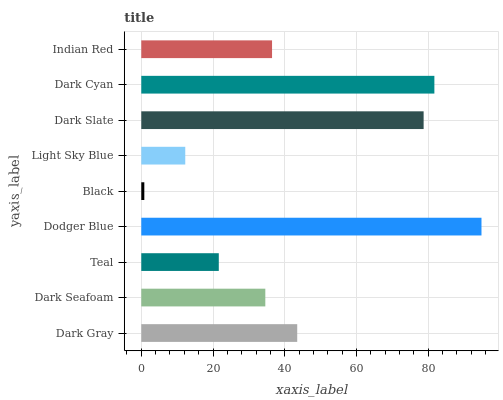Is Black the minimum?
Answer yes or no. Yes. Is Dodger Blue the maximum?
Answer yes or no. Yes. Is Dark Seafoam the minimum?
Answer yes or no. No. Is Dark Seafoam the maximum?
Answer yes or no. No. Is Dark Gray greater than Dark Seafoam?
Answer yes or no. Yes. Is Dark Seafoam less than Dark Gray?
Answer yes or no. Yes. Is Dark Seafoam greater than Dark Gray?
Answer yes or no. No. Is Dark Gray less than Dark Seafoam?
Answer yes or no. No. Is Indian Red the high median?
Answer yes or no. Yes. Is Indian Red the low median?
Answer yes or no. Yes. Is Light Sky Blue the high median?
Answer yes or no. No. Is Dark Gray the low median?
Answer yes or no. No. 